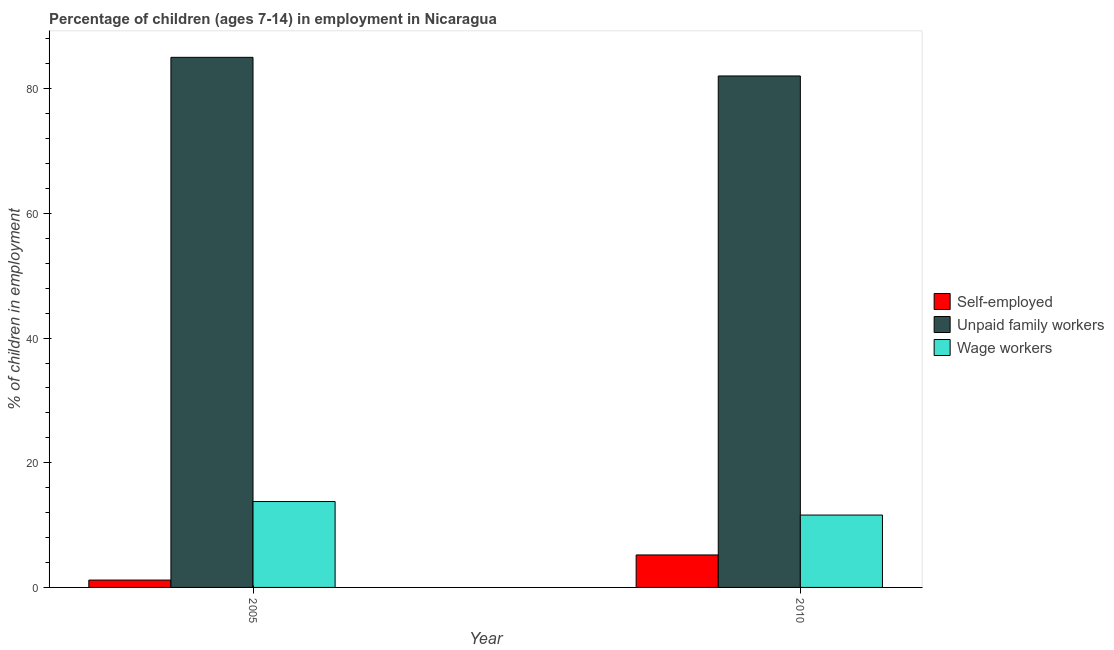How many different coloured bars are there?
Offer a very short reply. 3. Are the number of bars per tick equal to the number of legend labels?
Offer a terse response. Yes. Are the number of bars on each tick of the X-axis equal?
Offer a terse response. Yes. What is the percentage of children employed as unpaid family workers in 2005?
Your response must be concise. 85.04. Across all years, what is the maximum percentage of self employed children?
Your answer should be compact. 5.21. Across all years, what is the minimum percentage of children employed as unpaid family workers?
Offer a terse response. 82.05. In which year was the percentage of children employed as unpaid family workers minimum?
Keep it short and to the point. 2010. What is the total percentage of children employed as wage workers in the graph?
Your answer should be compact. 25.39. What is the difference between the percentage of children employed as wage workers in 2005 and that in 2010?
Your response must be concise. 2.17. What is the difference between the percentage of children employed as wage workers in 2010 and the percentage of self employed children in 2005?
Your response must be concise. -2.17. What is the average percentage of children employed as unpaid family workers per year?
Keep it short and to the point. 83.55. What is the ratio of the percentage of children employed as wage workers in 2005 to that in 2010?
Offer a terse response. 1.19. In how many years, is the percentage of children employed as unpaid family workers greater than the average percentage of children employed as unpaid family workers taken over all years?
Provide a short and direct response. 1. What does the 3rd bar from the left in 2010 represents?
Your response must be concise. Wage workers. What does the 1st bar from the right in 2005 represents?
Your response must be concise. Wage workers. Does the graph contain any zero values?
Provide a succinct answer. No. Where does the legend appear in the graph?
Keep it short and to the point. Center right. How are the legend labels stacked?
Your answer should be very brief. Vertical. What is the title of the graph?
Offer a terse response. Percentage of children (ages 7-14) in employment in Nicaragua. What is the label or title of the Y-axis?
Offer a terse response. % of children in employment. What is the % of children in employment in Self-employed in 2005?
Ensure brevity in your answer.  1.18. What is the % of children in employment of Unpaid family workers in 2005?
Ensure brevity in your answer.  85.04. What is the % of children in employment in Wage workers in 2005?
Keep it short and to the point. 13.78. What is the % of children in employment of Self-employed in 2010?
Provide a short and direct response. 5.21. What is the % of children in employment in Unpaid family workers in 2010?
Keep it short and to the point. 82.05. What is the % of children in employment of Wage workers in 2010?
Provide a succinct answer. 11.61. Across all years, what is the maximum % of children in employment in Self-employed?
Provide a succinct answer. 5.21. Across all years, what is the maximum % of children in employment in Unpaid family workers?
Your answer should be compact. 85.04. Across all years, what is the maximum % of children in employment in Wage workers?
Make the answer very short. 13.78. Across all years, what is the minimum % of children in employment of Self-employed?
Provide a succinct answer. 1.18. Across all years, what is the minimum % of children in employment in Unpaid family workers?
Give a very brief answer. 82.05. Across all years, what is the minimum % of children in employment in Wage workers?
Your response must be concise. 11.61. What is the total % of children in employment in Self-employed in the graph?
Ensure brevity in your answer.  6.39. What is the total % of children in employment of Unpaid family workers in the graph?
Your response must be concise. 167.09. What is the total % of children in employment in Wage workers in the graph?
Provide a short and direct response. 25.39. What is the difference between the % of children in employment in Self-employed in 2005 and that in 2010?
Provide a short and direct response. -4.03. What is the difference between the % of children in employment of Unpaid family workers in 2005 and that in 2010?
Your response must be concise. 2.99. What is the difference between the % of children in employment of Wage workers in 2005 and that in 2010?
Offer a terse response. 2.17. What is the difference between the % of children in employment of Self-employed in 2005 and the % of children in employment of Unpaid family workers in 2010?
Make the answer very short. -80.87. What is the difference between the % of children in employment in Self-employed in 2005 and the % of children in employment in Wage workers in 2010?
Your answer should be compact. -10.43. What is the difference between the % of children in employment in Unpaid family workers in 2005 and the % of children in employment in Wage workers in 2010?
Make the answer very short. 73.43. What is the average % of children in employment of Self-employed per year?
Give a very brief answer. 3.19. What is the average % of children in employment of Unpaid family workers per year?
Give a very brief answer. 83.55. What is the average % of children in employment in Wage workers per year?
Offer a very short reply. 12.7. In the year 2005, what is the difference between the % of children in employment of Self-employed and % of children in employment of Unpaid family workers?
Your response must be concise. -83.86. In the year 2005, what is the difference between the % of children in employment in Unpaid family workers and % of children in employment in Wage workers?
Your answer should be very brief. 71.26. In the year 2010, what is the difference between the % of children in employment of Self-employed and % of children in employment of Unpaid family workers?
Offer a very short reply. -76.84. In the year 2010, what is the difference between the % of children in employment of Self-employed and % of children in employment of Wage workers?
Make the answer very short. -6.4. In the year 2010, what is the difference between the % of children in employment in Unpaid family workers and % of children in employment in Wage workers?
Provide a succinct answer. 70.44. What is the ratio of the % of children in employment of Self-employed in 2005 to that in 2010?
Make the answer very short. 0.23. What is the ratio of the % of children in employment of Unpaid family workers in 2005 to that in 2010?
Make the answer very short. 1.04. What is the ratio of the % of children in employment of Wage workers in 2005 to that in 2010?
Ensure brevity in your answer.  1.19. What is the difference between the highest and the second highest % of children in employment of Self-employed?
Offer a very short reply. 4.03. What is the difference between the highest and the second highest % of children in employment of Unpaid family workers?
Your answer should be very brief. 2.99. What is the difference between the highest and the second highest % of children in employment of Wage workers?
Make the answer very short. 2.17. What is the difference between the highest and the lowest % of children in employment in Self-employed?
Make the answer very short. 4.03. What is the difference between the highest and the lowest % of children in employment in Unpaid family workers?
Keep it short and to the point. 2.99. What is the difference between the highest and the lowest % of children in employment in Wage workers?
Give a very brief answer. 2.17. 